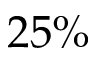Convert formula to latex. <formula><loc_0><loc_0><loc_500><loc_500>2 5 \%</formula> 